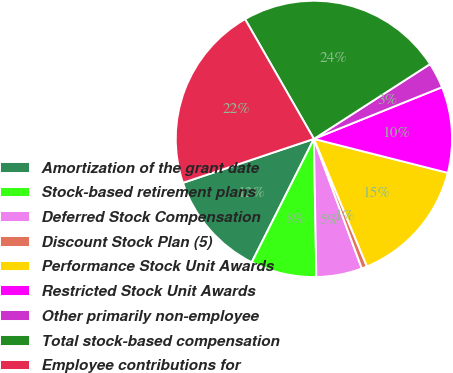Convert chart to OTSL. <chart><loc_0><loc_0><loc_500><loc_500><pie_chart><fcel>Amortization of the grant date<fcel>Stock-based retirement plans<fcel>Deferred Stock Compensation<fcel>Discount Stock Plan (5)<fcel>Performance Stock Unit Awards<fcel>Restricted Stock Unit Awards<fcel>Other primarily non-employee<fcel>Total stock-based compensation<fcel>Employee contributions for<nl><fcel>12.42%<fcel>7.71%<fcel>5.35%<fcel>0.64%<fcel>14.77%<fcel>10.06%<fcel>3.0%<fcel>24.19%<fcel>21.84%<nl></chart> 